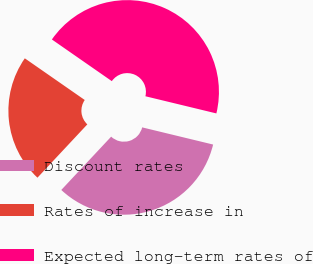<chart> <loc_0><loc_0><loc_500><loc_500><pie_chart><fcel>Discount rates<fcel>Rates of increase in<fcel>Expected long-term rates of<nl><fcel>33.19%<fcel>22.7%<fcel>44.11%<nl></chart> 